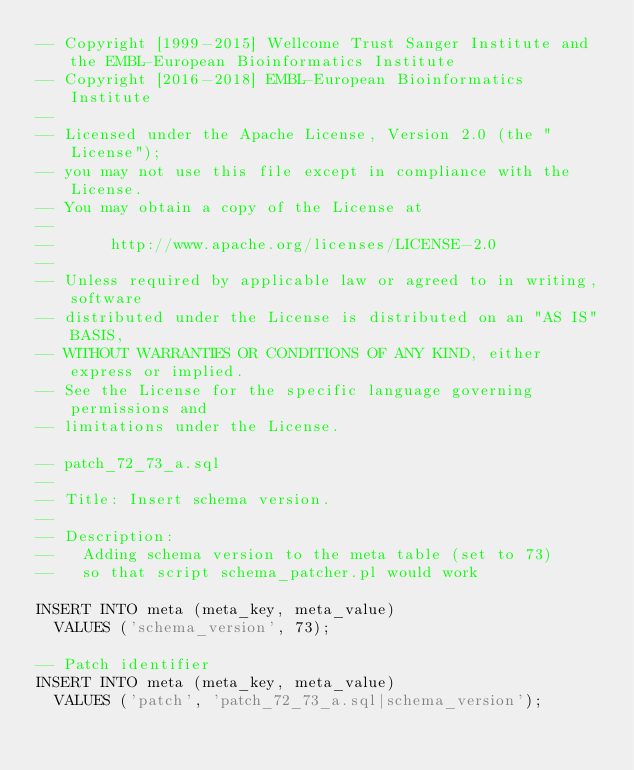<code> <loc_0><loc_0><loc_500><loc_500><_SQL_>-- Copyright [1999-2015] Wellcome Trust Sanger Institute and the EMBL-European Bioinformatics Institute
-- Copyright [2016-2018] EMBL-European Bioinformatics Institute
-- 
-- Licensed under the Apache License, Version 2.0 (the "License");
-- you may not use this file except in compliance with the License.
-- You may obtain a copy of the License at
-- 
--      http://www.apache.org/licenses/LICENSE-2.0
-- 
-- Unless required by applicable law or agreed to in writing, software
-- distributed under the License is distributed on an "AS IS" BASIS,
-- WITHOUT WARRANTIES OR CONDITIONS OF ANY KIND, either express or implied.
-- See the License for the specific language governing permissions and
-- limitations under the License.

-- patch_72_73_a.sql
--
-- Title: Insert schema version.
--
-- Description:
--   Adding schema version to the meta table (set to 73)
--   so that script schema_patcher.pl would work

INSERT INTO meta (meta_key, meta_value)
  VALUES ('schema_version', 73);

-- Patch identifier
INSERT INTO meta (meta_key, meta_value)
  VALUES ('patch', 'patch_72_73_a.sql|schema_version');


</code> 